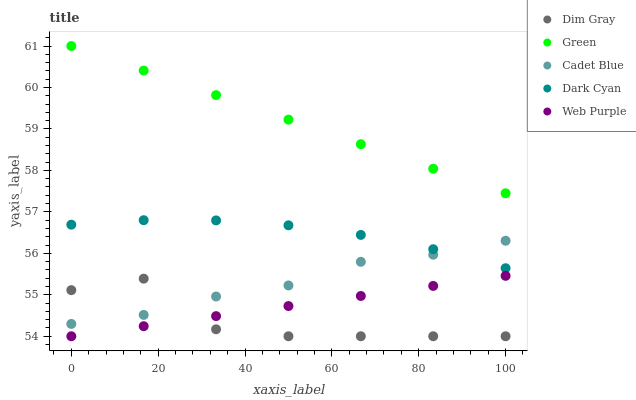Does Dim Gray have the minimum area under the curve?
Answer yes or no. Yes. Does Green have the maximum area under the curve?
Answer yes or no. Yes. Does Dark Cyan have the minimum area under the curve?
Answer yes or no. No. Does Dark Cyan have the maximum area under the curve?
Answer yes or no. No. Is Web Purple the smoothest?
Answer yes or no. Yes. Is Dim Gray the roughest?
Answer yes or no. Yes. Is Dark Cyan the smoothest?
Answer yes or no. No. Is Dark Cyan the roughest?
Answer yes or no. No. Does Web Purple have the lowest value?
Answer yes or no. Yes. Does Dark Cyan have the lowest value?
Answer yes or no. No. Does Green have the highest value?
Answer yes or no. Yes. Does Dark Cyan have the highest value?
Answer yes or no. No. Is Web Purple less than Cadet Blue?
Answer yes or no. Yes. Is Green greater than Dim Gray?
Answer yes or no. Yes. Does Dim Gray intersect Web Purple?
Answer yes or no. Yes. Is Dim Gray less than Web Purple?
Answer yes or no. No. Is Dim Gray greater than Web Purple?
Answer yes or no. No. Does Web Purple intersect Cadet Blue?
Answer yes or no. No. 